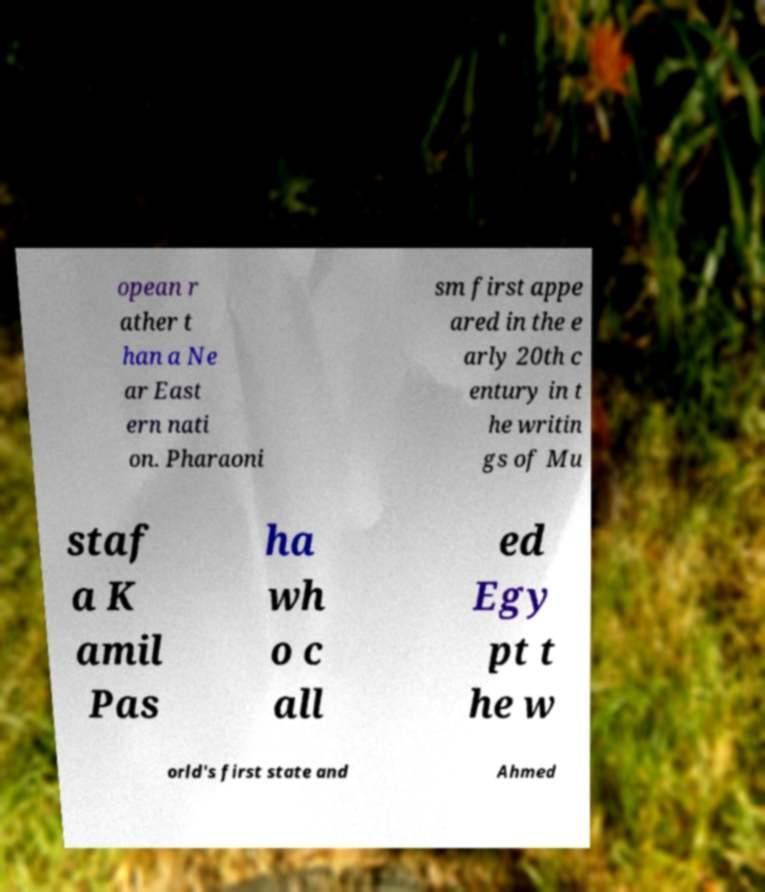Can you read and provide the text displayed in the image?This photo seems to have some interesting text. Can you extract and type it out for me? opean r ather t han a Ne ar East ern nati on. Pharaoni sm first appe ared in the e arly 20th c entury in t he writin gs of Mu staf a K amil Pas ha wh o c all ed Egy pt t he w orld's first state and Ahmed 